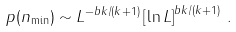Convert formula to latex. <formula><loc_0><loc_0><loc_500><loc_500>p ( n _ { \min } ) \sim L ^ { - b k / ( k + 1 ) } \left [ \ln L \right ] ^ { b k / ( k + 1 ) } \, .</formula> 